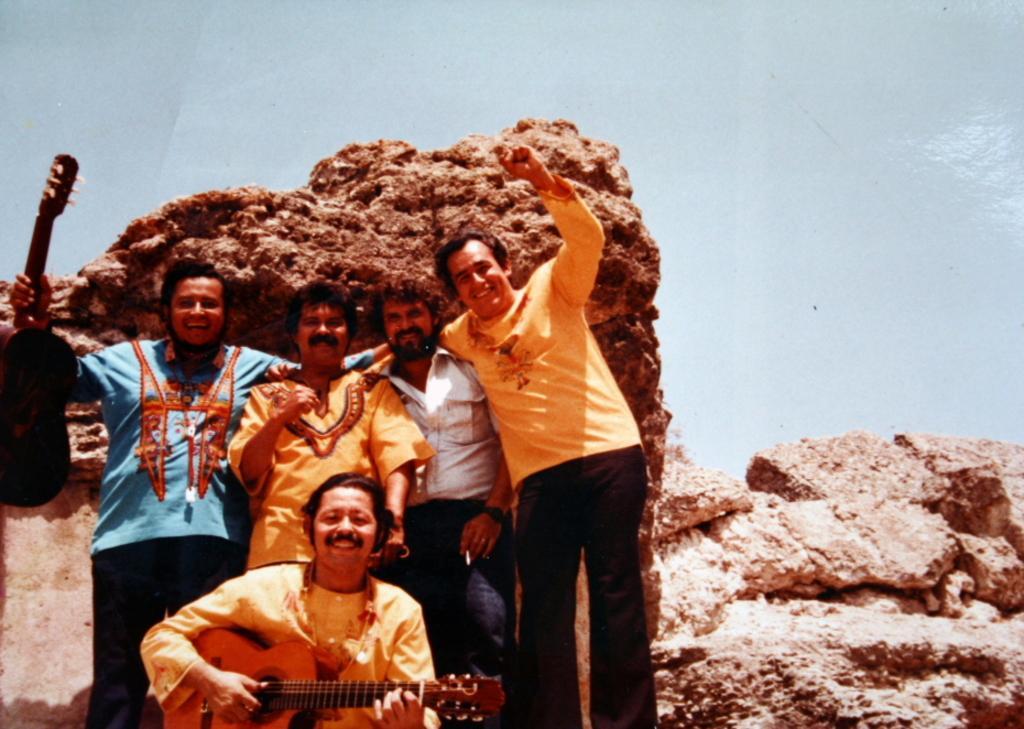How would you summarize this image in a sentence or two? In this image I can see a group of people among them, few are standing and few are sitting and holding a guitar in their hand. 